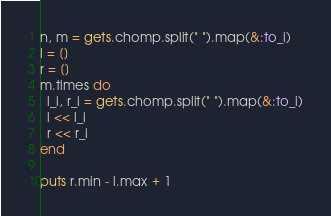<code> <loc_0><loc_0><loc_500><loc_500><_Ruby_>n, m = gets.chomp.split(" ").map(&:to_i)
l = []
r = []
m.times do
  l_i, r_i = gets.chomp.split(" ").map(&:to_i)
  l << l_i
  r << r_i
end

puts r.min - l.max + 1
</code> 